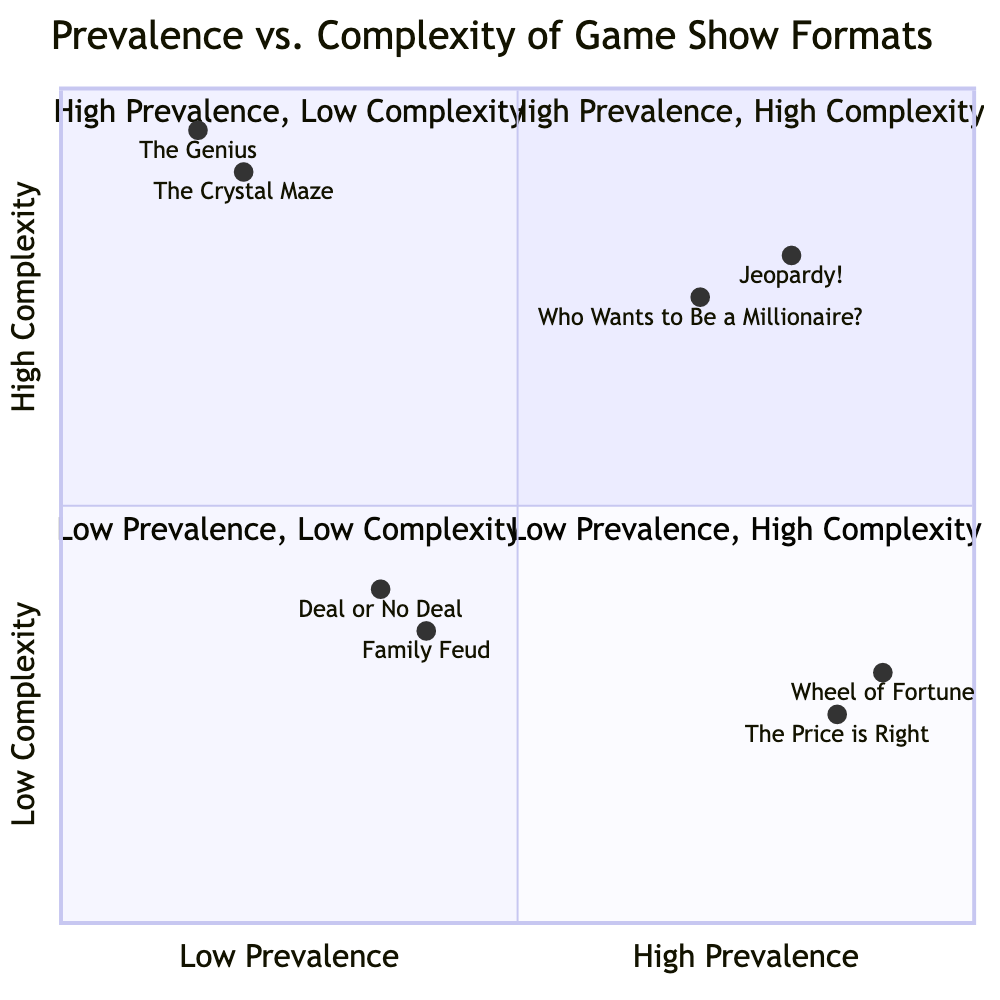What game show is located in the High Prevalence, Low Complexity quadrant? Referring to the diagram's categorization, "Wheel of Fortune" and "The Price is Right" occupy the High Prevalence, Low Complexity quadrant, indicating they are popular but not overly complex.
Answer: Wheel of Fortune How many game shows are in the Low Prevalence, High Complexity quadrant? By checking the diagram, there are two game shows listed in the Low Prevalence, High Complexity quadrant: "The Crystal Maze" and "The Genius".
Answer: 2 Which game show has the highest complexity? "The Genius" is positioned at the highest point in the diagram, representing the highest complexity among all shows.
Answer: The Genius What is the prevalence rating of "The Price is Right"? The chart indicates that "The Price is Right" has a prevalence rating of 0.85, which is high on the 0 to 1 scale.
Answer: 0.85 In which quadrant would you find "Family Feud"? "Family Feud" is positioned in the Low Prevalence, Low Complexity quadrant, showing it is less popular and simpler in format.
Answer: Low Prevalence, Low Complexity Which two game shows have the same prevalence? "Wheel of Fortune" and "The Price is Right" both have a prevalence of 0.85, indicating they are equally popular.
Answer: Wheel of Fortune, The Price is Right What is the prevalence and complexity of "Jeopardy!"? According to the diagram, "Jeopardy!" has a prevalence rating of 0.8 and a complexity rating of 0.8, showing it is both popular and complex.
Answer: 0.8, 0.8 Which quadrant contains game shows with the lowest complexity? The Low Complexity quadrant includes shows like "Wheel of Fortune," "The Price is Right," "Family Feud," and "Deal or No Deal," all of which demonstrate lower complexity attributes.
Answer: Low Complexity What does the diagram suggest about the relationship between prevalence and complexity? The diagram reveals that shows with high prevalence don't always have high complexity, as demonstrated in the High Prevalence, Low Complexity quadrant, while the opposite can also be seen.
Answer: High Prevalence, Low Complexity 